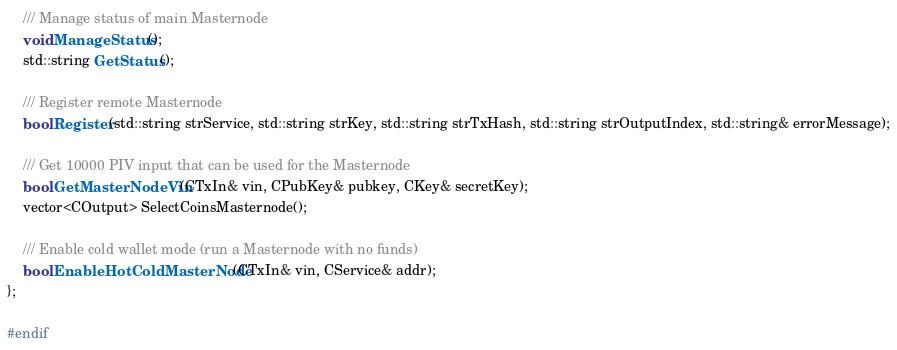<code> <loc_0><loc_0><loc_500><loc_500><_C_>
    /// Manage status of main Masternode
    void ManageStatus();
    std::string GetStatus();

    /// Register remote Masternode
    bool Register(std::string strService, std::string strKey, std::string strTxHash, std::string strOutputIndex, std::string& errorMessage);

    /// Get 10000 PIV input that can be used for the Masternode
    bool GetMasterNodeVin(CTxIn& vin, CPubKey& pubkey, CKey& secretKey);
    vector<COutput> SelectCoinsMasternode();

    /// Enable cold wallet mode (run a Masternode with no funds)
    bool EnableHotColdMasterNode(CTxIn& vin, CService& addr);
};

#endif
</code> 